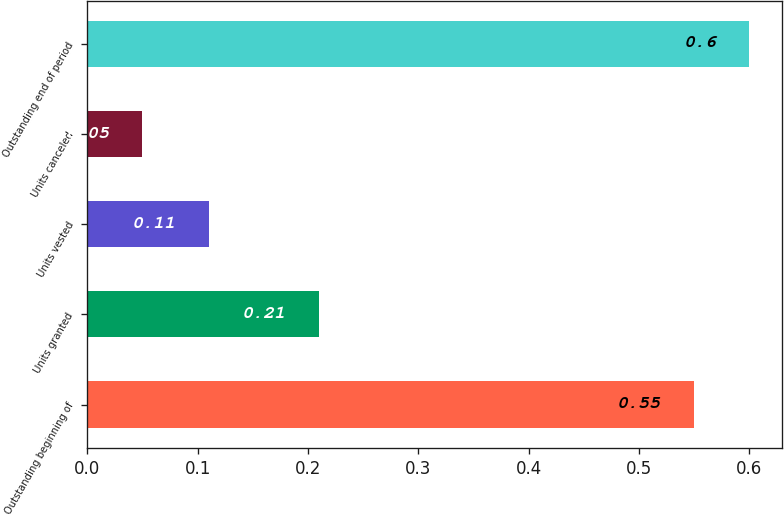Convert chart. <chart><loc_0><loc_0><loc_500><loc_500><bar_chart><fcel>Outstanding beginning of<fcel>Units granted<fcel>Units vested<fcel>Units canceled<fcel>Outstanding end of period<nl><fcel>0.55<fcel>0.21<fcel>0.11<fcel>0.05<fcel>0.6<nl></chart> 